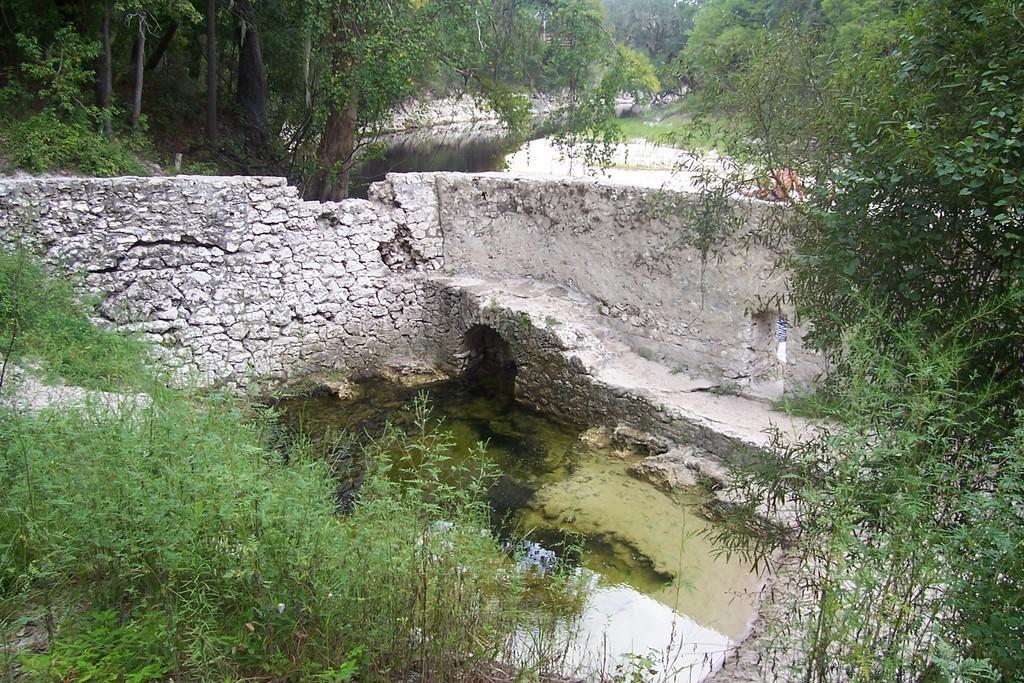Please provide a concise description of this image. In this picture we can see few lights, plants, water and trees, and also we can see a person on the right side of the image. 